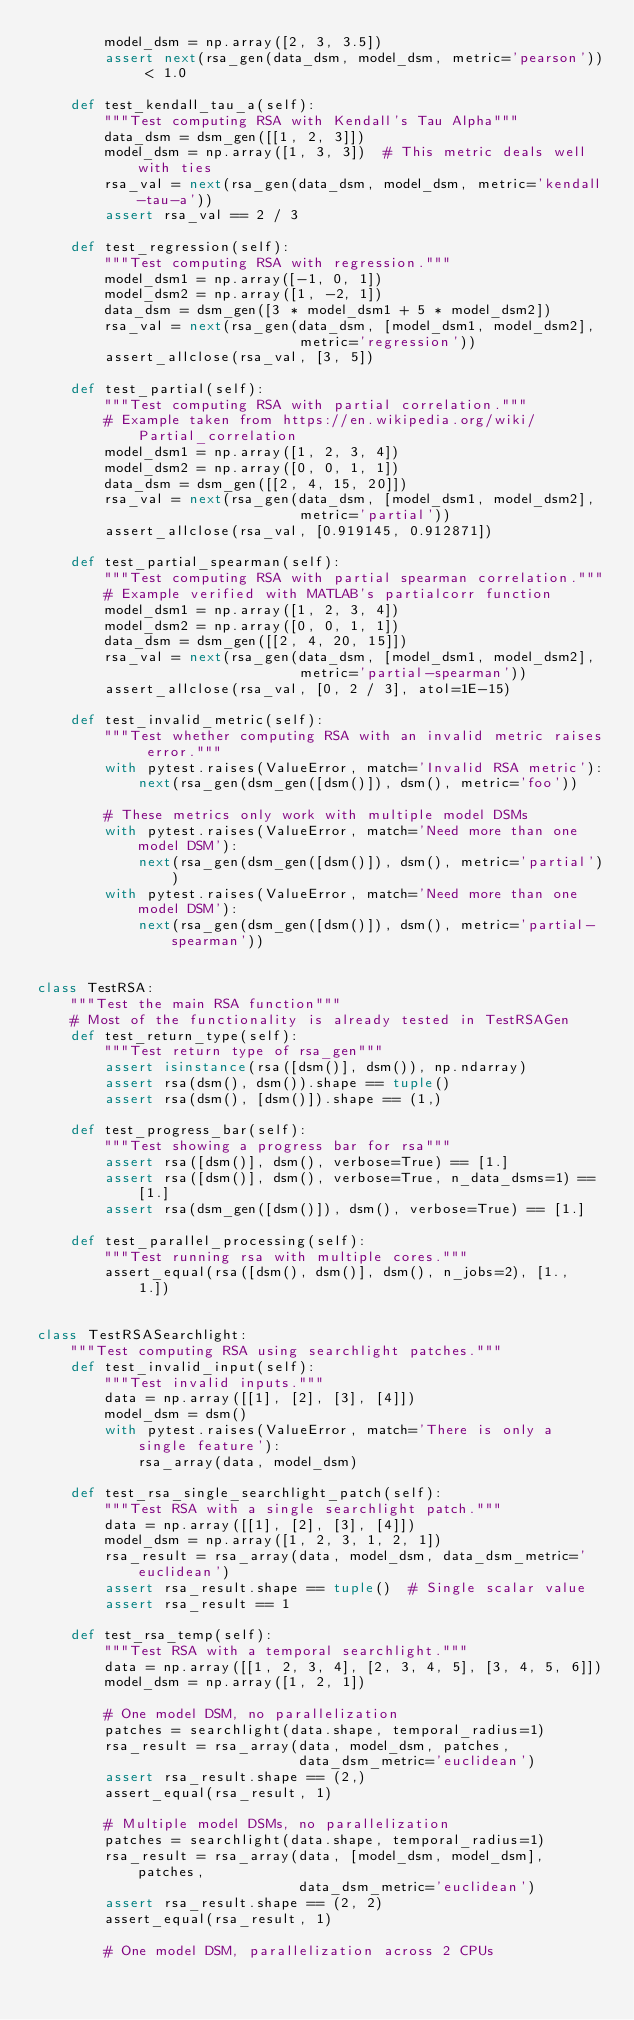Convert code to text. <code><loc_0><loc_0><loc_500><loc_500><_Python_>        model_dsm = np.array([2, 3, 3.5])
        assert next(rsa_gen(data_dsm, model_dsm, metric='pearson')) < 1.0

    def test_kendall_tau_a(self):
        """Test computing RSA with Kendall's Tau Alpha"""
        data_dsm = dsm_gen([[1, 2, 3]])
        model_dsm = np.array([1, 3, 3])  # This metric deals well with ties
        rsa_val = next(rsa_gen(data_dsm, model_dsm, metric='kendall-tau-a'))
        assert rsa_val == 2 / 3

    def test_regression(self):
        """Test computing RSA with regression."""
        model_dsm1 = np.array([-1, 0, 1])
        model_dsm2 = np.array([1, -2, 1])
        data_dsm = dsm_gen([3 * model_dsm1 + 5 * model_dsm2])
        rsa_val = next(rsa_gen(data_dsm, [model_dsm1, model_dsm2],
                               metric='regression'))
        assert_allclose(rsa_val, [3, 5])

    def test_partial(self):
        """Test computing RSA with partial correlation."""
        # Example taken from https://en.wikipedia.org/wiki/Partial_correlation
        model_dsm1 = np.array([1, 2, 3, 4])
        model_dsm2 = np.array([0, 0, 1, 1])
        data_dsm = dsm_gen([[2, 4, 15, 20]])
        rsa_val = next(rsa_gen(data_dsm, [model_dsm1, model_dsm2],
                               metric='partial'))
        assert_allclose(rsa_val, [0.919145, 0.912871])

    def test_partial_spearman(self):
        """Test computing RSA with partial spearman correlation."""
        # Example verified with MATLAB's partialcorr function
        model_dsm1 = np.array([1, 2, 3, 4])
        model_dsm2 = np.array([0, 0, 1, 1])
        data_dsm = dsm_gen([[2, 4, 20, 15]])
        rsa_val = next(rsa_gen(data_dsm, [model_dsm1, model_dsm2],
                               metric='partial-spearman'))
        assert_allclose(rsa_val, [0, 2 / 3], atol=1E-15)

    def test_invalid_metric(self):
        """Test whether computing RSA with an invalid metric raises error."""
        with pytest.raises(ValueError, match='Invalid RSA metric'):
            next(rsa_gen(dsm_gen([dsm()]), dsm(), metric='foo'))

        # These metrics only work with multiple model DSMs
        with pytest.raises(ValueError, match='Need more than one model DSM'):
            next(rsa_gen(dsm_gen([dsm()]), dsm(), metric='partial'))
        with pytest.raises(ValueError, match='Need more than one model DSM'):
            next(rsa_gen(dsm_gen([dsm()]), dsm(), metric='partial-spearman'))


class TestRSA:
    """Test the main RSA function"""
    # Most of the functionality is already tested in TestRSAGen
    def test_return_type(self):
        """Test return type of rsa_gen"""
        assert isinstance(rsa([dsm()], dsm()), np.ndarray)
        assert rsa(dsm(), dsm()).shape == tuple()
        assert rsa(dsm(), [dsm()]).shape == (1,)

    def test_progress_bar(self):
        """Test showing a progress bar for rsa"""
        assert rsa([dsm()], dsm(), verbose=True) == [1.]
        assert rsa([dsm()], dsm(), verbose=True, n_data_dsms=1) == [1.]
        assert rsa(dsm_gen([dsm()]), dsm(), verbose=True) == [1.]

    def test_parallel_processing(self):
        """Test running rsa with multiple cores."""
        assert_equal(rsa([dsm(), dsm()], dsm(), n_jobs=2), [1., 1.])


class TestRSASearchlight:
    """Test computing RSA using searchlight patches."""
    def test_invalid_input(self):
        """Test invalid inputs."""
        data = np.array([[1], [2], [3], [4]])
        model_dsm = dsm()
        with pytest.raises(ValueError, match='There is only a single feature'):
            rsa_array(data, model_dsm)

    def test_rsa_single_searchlight_patch(self):
        """Test RSA with a single searchlight patch."""
        data = np.array([[1], [2], [3], [4]])
        model_dsm = np.array([1, 2, 3, 1, 2, 1])
        rsa_result = rsa_array(data, model_dsm, data_dsm_metric='euclidean')
        assert rsa_result.shape == tuple()  # Single scalar value
        assert rsa_result == 1

    def test_rsa_temp(self):
        """Test RSA with a temporal searchlight."""
        data = np.array([[1, 2, 3, 4], [2, 3, 4, 5], [3, 4, 5, 6]])
        model_dsm = np.array([1, 2, 1])

        # One model DSM, no parallelization
        patches = searchlight(data.shape, temporal_radius=1)
        rsa_result = rsa_array(data, model_dsm, patches,
                               data_dsm_metric='euclidean')
        assert rsa_result.shape == (2,)
        assert_equal(rsa_result, 1)

        # Multiple model DSMs, no parallelization
        patches = searchlight(data.shape, temporal_radius=1)
        rsa_result = rsa_array(data, [model_dsm, model_dsm], patches,
                               data_dsm_metric='euclidean')
        assert rsa_result.shape == (2, 2)
        assert_equal(rsa_result, 1)

        # One model DSM, parallelization across 2 CPUs</code> 